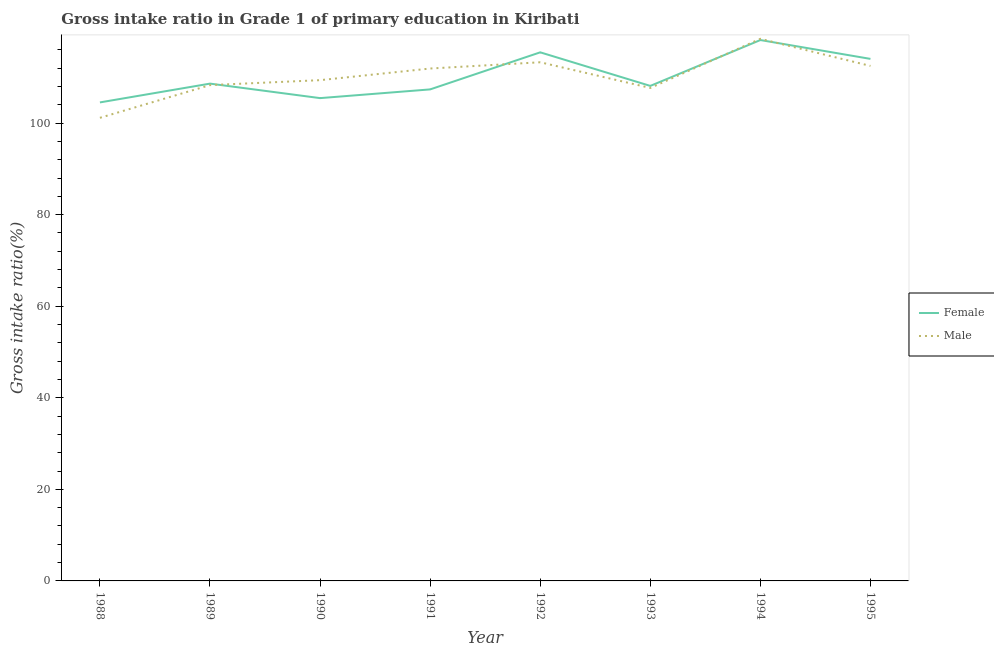Does the line corresponding to gross intake ratio(female) intersect with the line corresponding to gross intake ratio(male)?
Give a very brief answer. Yes. Is the number of lines equal to the number of legend labels?
Your answer should be compact. Yes. What is the gross intake ratio(female) in 1994?
Your answer should be very brief. 118.13. Across all years, what is the maximum gross intake ratio(male)?
Ensure brevity in your answer.  118.4. Across all years, what is the minimum gross intake ratio(female)?
Make the answer very short. 104.51. In which year was the gross intake ratio(female) maximum?
Offer a very short reply. 1994. In which year was the gross intake ratio(female) minimum?
Your answer should be compact. 1988. What is the total gross intake ratio(male) in the graph?
Offer a very short reply. 882.54. What is the difference between the gross intake ratio(male) in 1988 and that in 1989?
Give a very brief answer. -7.15. What is the difference between the gross intake ratio(male) in 1991 and the gross intake ratio(female) in 1988?
Ensure brevity in your answer.  7.4. What is the average gross intake ratio(male) per year?
Ensure brevity in your answer.  110.32. In the year 1990, what is the difference between the gross intake ratio(female) and gross intake ratio(male)?
Provide a short and direct response. -3.92. What is the ratio of the gross intake ratio(female) in 1989 to that in 1991?
Your response must be concise. 1.01. Is the gross intake ratio(female) in 1988 less than that in 1990?
Your answer should be very brief. Yes. Is the difference between the gross intake ratio(male) in 1994 and 1995 greater than the difference between the gross intake ratio(female) in 1994 and 1995?
Your answer should be compact. Yes. What is the difference between the highest and the second highest gross intake ratio(male)?
Your answer should be compact. 5.12. What is the difference between the highest and the lowest gross intake ratio(male)?
Provide a short and direct response. 17.25. In how many years, is the gross intake ratio(female) greater than the average gross intake ratio(female) taken over all years?
Give a very brief answer. 3. Is the gross intake ratio(male) strictly greater than the gross intake ratio(female) over the years?
Ensure brevity in your answer.  No. Is the gross intake ratio(female) strictly less than the gross intake ratio(male) over the years?
Provide a short and direct response. No. How many lines are there?
Give a very brief answer. 2. Are the values on the major ticks of Y-axis written in scientific E-notation?
Keep it short and to the point. No. Does the graph contain any zero values?
Offer a terse response. No. Does the graph contain grids?
Ensure brevity in your answer.  No. How many legend labels are there?
Your answer should be very brief. 2. What is the title of the graph?
Your response must be concise. Gross intake ratio in Grade 1 of primary education in Kiribati. Does "2012 US$" appear as one of the legend labels in the graph?
Offer a very short reply. No. What is the label or title of the X-axis?
Keep it short and to the point. Year. What is the label or title of the Y-axis?
Your response must be concise. Gross intake ratio(%). What is the Gross intake ratio(%) of Female in 1988?
Keep it short and to the point. 104.51. What is the Gross intake ratio(%) in Male in 1988?
Ensure brevity in your answer.  101.14. What is the Gross intake ratio(%) in Female in 1989?
Keep it short and to the point. 108.61. What is the Gross intake ratio(%) of Male in 1989?
Your answer should be very brief. 108.29. What is the Gross intake ratio(%) of Female in 1990?
Ensure brevity in your answer.  105.45. What is the Gross intake ratio(%) in Male in 1990?
Your answer should be compact. 109.37. What is the Gross intake ratio(%) in Female in 1991?
Your response must be concise. 107.35. What is the Gross intake ratio(%) in Male in 1991?
Provide a short and direct response. 111.91. What is the Gross intake ratio(%) in Female in 1992?
Ensure brevity in your answer.  115.45. What is the Gross intake ratio(%) of Male in 1992?
Your answer should be very brief. 113.28. What is the Gross intake ratio(%) in Female in 1993?
Keep it short and to the point. 108.11. What is the Gross intake ratio(%) of Male in 1993?
Your answer should be very brief. 107.67. What is the Gross intake ratio(%) of Female in 1994?
Your answer should be very brief. 118.13. What is the Gross intake ratio(%) of Male in 1994?
Offer a very short reply. 118.4. What is the Gross intake ratio(%) of Female in 1995?
Your answer should be compact. 114.01. What is the Gross intake ratio(%) in Male in 1995?
Provide a succinct answer. 112.48. Across all years, what is the maximum Gross intake ratio(%) of Female?
Give a very brief answer. 118.13. Across all years, what is the maximum Gross intake ratio(%) in Male?
Your answer should be very brief. 118.4. Across all years, what is the minimum Gross intake ratio(%) in Female?
Keep it short and to the point. 104.51. Across all years, what is the minimum Gross intake ratio(%) of Male?
Make the answer very short. 101.14. What is the total Gross intake ratio(%) in Female in the graph?
Keep it short and to the point. 881.62. What is the total Gross intake ratio(%) in Male in the graph?
Provide a succinct answer. 882.54. What is the difference between the Gross intake ratio(%) of Female in 1988 and that in 1989?
Provide a succinct answer. -4.1. What is the difference between the Gross intake ratio(%) in Male in 1988 and that in 1989?
Give a very brief answer. -7.15. What is the difference between the Gross intake ratio(%) in Female in 1988 and that in 1990?
Keep it short and to the point. -0.94. What is the difference between the Gross intake ratio(%) of Male in 1988 and that in 1990?
Provide a short and direct response. -8.23. What is the difference between the Gross intake ratio(%) of Female in 1988 and that in 1991?
Give a very brief answer. -2.84. What is the difference between the Gross intake ratio(%) in Male in 1988 and that in 1991?
Make the answer very short. -10.77. What is the difference between the Gross intake ratio(%) in Female in 1988 and that in 1992?
Make the answer very short. -10.93. What is the difference between the Gross intake ratio(%) of Male in 1988 and that in 1992?
Provide a succinct answer. -12.13. What is the difference between the Gross intake ratio(%) of Female in 1988 and that in 1993?
Your answer should be very brief. -3.6. What is the difference between the Gross intake ratio(%) of Male in 1988 and that in 1993?
Your answer should be compact. -6.53. What is the difference between the Gross intake ratio(%) of Female in 1988 and that in 1994?
Keep it short and to the point. -13.62. What is the difference between the Gross intake ratio(%) in Male in 1988 and that in 1994?
Offer a terse response. -17.25. What is the difference between the Gross intake ratio(%) of Female in 1988 and that in 1995?
Provide a short and direct response. -9.5. What is the difference between the Gross intake ratio(%) in Male in 1988 and that in 1995?
Provide a succinct answer. -11.33. What is the difference between the Gross intake ratio(%) in Female in 1989 and that in 1990?
Your answer should be very brief. 3.17. What is the difference between the Gross intake ratio(%) in Male in 1989 and that in 1990?
Make the answer very short. -1.08. What is the difference between the Gross intake ratio(%) of Female in 1989 and that in 1991?
Your response must be concise. 1.26. What is the difference between the Gross intake ratio(%) in Male in 1989 and that in 1991?
Give a very brief answer. -3.62. What is the difference between the Gross intake ratio(%) of Female in 1989 and that in 1992?
Your answer should be very brief. -6.83. What is the difference between the Gross intake ratio(%) of Male in 1989 and that in 1992?
Provide a short and direct response. -4.99. What is the difference between the Gross intake ratio(%) of Female in 1989 and that in 1993?
Your answer should be very brief. 0.5. What is the difference between the Gross intake ratio(%) in Male in 1989 and that in 1993?
Your answer should be compact. 0.62. What is the difference between the Gross intake ratio(%) in Female in 1989 and that in 1994?
Your answer should be compact. -9.52. What is the difference between the Gross intake ratio(%) in Male in 1989 and that in 1994?
Provide a short and direct response. -10.11. What is the difference between the Gross intake ratio(%) in Female in 1989 and that in 1995?
Your response must be concise. -5.4. What is the difference between the Gross intake ratio(%) in Male in 1989 and that in 1995?
Give a very brief answer. -4.19. What is the difference between the Gross intake ratio(%) of Female in 1990 and that in 1991?
Make the answer very short. -1.9. What is the difference between the Gross intake ratio(%) of Male in 1990 and that in 1991?
Provide a short and direct response. -2.54. What is the difference between the Gross intake ratio(%) of Female in 1990 and that in 1992?
Provide a short and direct response. -10. What is the difference between the Gross intake ratio(%) of Male in 1990 and that in 1992?
Your answer should be very brief. -3.91. What is the difference between the Gross intake ratio(%) in Female in 1990 and that in 1993?
Provide a succinct answer. -2.67. What is the difference between the Gross intake ratio(%) in Male in 1990 and that in 1993?
Give a very brief answer. 1.7. What is the difference between the Gross intake ratio(%) in Female in 1990 and that in 1994?
Your answer should be very brief. -12.68. What is the difference between the Gross intake ratio(%) of Male in 1990 and that in 1994?
Your answer should be very brief. -9.03. What is the difference between the Gross intake ratio(%) in Female in 1990 and that in 1995?
Provide a succinct answer. -8.57. What is the difference between the Gross intake ratio(%) of Male in 1990 and that in 1995?
Keep it short and to the point. -3.11. What is the difference between the Gross intake ratio(%) of Female in 1991 and that in 1992?
Your answer should be compact. -8.09. What is the difference between the Gross intake ratio(%) in Male in 1991 and that in 1992?
Provide a succinct answer. -1.37. What is the difference between the Gross intake ratio(%) in Female in 1991 and that in 1993?
Make the answer very short. -0.76. What is the difference between the Gross intake ratio(%) in Male in 1991 and that in 1993?
Provide a succinct answer. 4.24. What is the difference between the Gross intake ratio(%) of Female in 1991 and that in 1994?
Offer a terse response. -10.78. What is the difference between the Gross intake ratio(%) in Male in 1991 and that in 1994?
Your response must be concise. -6.49. What is the difference between the Gross intake ratio(%) in Female in 1991 and that in 1995?
Your answer should be compact. -6.66. What is the difference between the Gross intake ratio(%) of Male in 1991 and that in 1995?
Offer a very short reply. -0.57. What is the difference between the Gross intake ratio(%) in Female in 1992 and that in 1993?
Give a very brief answer. 7.33. What is the difference between the Gross intake ratio(%) in Male in 1992 and that in 1993?
Offer a terse response. 5.61. What is the difference between the Gross intake ratio(%) of Female in 1992 and that in 1994?
Make the answer very short. -2.68. What is the difference between the Gross intake ratio(%) in Male in 1992 and that in 1994?
Your answer should be very brief. -5.12. What is the difference between the Gross intake ratio(%) of Female in 1992 and that in 1995?
Provide a short and direct response. 1.43. What is the difference between the Gross intake ratio(%) in Male in 1992 and that in 1995?
Provide a short and direct response. 0.8. What is the difference between the Gross intake ratio(%) of Female in 1993 and that in 1994?
Offer a terse response. -10.02. What is the difference between the Gross intake ratio(%) of Male in 1993 and that in 1994?
Ensure brevity in your answer.  -10.73. What is the difference between the Gross intake ratio(%) of Female in 1993 and that in 1995?
Offer a terse response. -5.9. What is the difference between the Gross intake ratio(%) in Male in 1993 and that in 1995?
Your answer should be compact. -4.81. What is the difference between the Gross intake ratio(%) in Female in 1994 and that in 1995?
Make the answer very short. 4.12. What is the difference between the Gross intake ratio(%) in Male in 1994 and that in 1995?
Your answer should be compact. 5.92. What is the difference between the Gross intake ratio(%) of Female in 1988 and the Gross intake ratio(%) of Male in 1989?
Ensure brevity in your answer.  -3.78. What is the difference between the Gross intake ratio(%) in Female in 1988 and the Gross intake ratio(%) in Male in 1990?
Give a very brief answer. -4.86. What is the difference between the Gross intake ratio(%) in Female in 1988 and the Gross intake ratio(%) in Male in 1991?
Ensure brevity in your answer.  -7.4. What is the difference between the Gross intake ratio(%) of Female in 1988 and the Gross intake ratio(%) of Male in 1992?
Ensure brevity in your answer.  -8.77. What is the difference between the Gross intake ratio(%) of Female in 1988 and the Gross intake ratio(%) of Male in 1993?
Your answer should be compact. -3.16. What is the difference between the Gross intake ratio(%) in Female in 1988 and the Gross intake ratio(%) in Male in 1994?
Ensure brevity in your answer.  -13.89. What is the difference between the Gross intake ratio(%) of Female in 1988 and the Gross intake ratio(%) of Male in 1995?
Your answer should be very brief. -7.97. What is the difference between the Gross intake ratio(%) in Female in 1989 and the Gross intake ratio(%) in Male in 1990?
Your answer should be very brief. -0.76. What is the difference between the Gross intake ratio(%) in Female in 1989 and the Gross intake ratio(%) in Male in 1991?
Offer a terse response. -3.3. What is the difference between the Gross intake ratio(%) in Female in 1989 and the Gross intake ratio(%) in Male in 1992?
Give a very brief answer. -4.66. What is the difference between the Gross intake ratio(%) of Female in 1989 and the Gross intake ratio(%) of Male in 1993?
Your answer should be compact. 0.94. What is the difference between the Gross intake ratio(%) of Female in 1989 and the Gross intake ratio(%) of Male in 1994?
Keep it short and to the point. -9.78. What is the difference between the Gross intake ratio(%) of Female in 1989 and the Gross intake ratio(%) of Male in 1995?
Keep it short and to the point. -3.86. What is the difference between the Gross intake ratio(%) in Female in 1990 and the Gross intake ratio(%) in Male in 1991?
Your answer should be very brief. -6.46. What is the difference between the Gross intake ratio(%) in Female in 1990 and the Gross intake ratio(%) in Male in 1992?
Your response must be concise. -7.83. What is the difference between the Gross intake ratio(%) in Female in 1990 and the Gross intake ratio(%) in Male in 1993?
Provide a short and direct response. -2.22. What is the difference between the Gross intake ratio(%) of Female in 1990 and the Gross intake ratio(%) of Male in 1994?
Offer a terse response. -12.95. What is the difference between the Gross intake ratio(%) of Female in 1990 and the Gross intake ratio(%) of Male in 1995?
Your answer should be very brief. -7.03. What is the difference between the Gross intake ratio(%) of Female in 1991 and the Gross intake ratio(%) of Male in 1992?
Ensure brevity in your answer.  -5.93. What is the difference between the Gross intake ratio(%) of Female in 1991 and the Gross intake ratio(%) of Male in 1993?
Offer a terse response. -0.32. What is the difference between the Gross intake ratio(%) in Female in 1991 and the Gross intake ratio(%) in Male in 1994?
Give a very brief answer. -11.05. What is the difference between the Gross intake ratio(%) of Female in 1991 and the Gross intake ratio(%) of Male in 1995?
Offer a very short reply. -5.13. What is the difference between the Gross intake ratio(%) in Female in 1992 and the Gross intake ratio(%) in Male in 1993?
Ensure brevity in your answer.  7.77. What is the difference between the Gross intake ratio(%) in Female in 1992 and the Gross intake ratio(%) in Male in 1994?
Your response must be concise. -2.95. What is the difference between the Gross intake ratio(%) in Female in 1992 and the Gross intake ratio(%) in Male in 1995?
Provide a short and direct response. 2.97. What is the difference between the Gross intake ratio(%) of Female in 1993 and the Gross intake ratio(%) of Male in 1994?
Keep it short and to the point. -10.28. What is the difference between the Gross intake ratio(%) of Female in 1993 and the Gross intake ratio(%) of Male in 1995?
Your answer should be compact. -4.36. What is the difference between the Gross intake ratio(%) of Female in 1994 and the Gross intake ratio(%) of Male in 1995?
Your answer should be very brief. 5.65. What is the average Gross intake ratio(%) in Female per year?
Provide a short and direct response. 110.2. What is the average Gross intake ratio(%) in Male per year?
Offer a terse response. 110.32. In the year 1988, what is the difference between the Gross intake ratio(%) in Female and Gross intake ratio(%) in Male?
Your response must be concise. 3.37. In the year 1989, what is the difference between the Gross intake ratio(%) of Female and Gross intake ratio(%) of Male?
Offer a terse response. 0.32. In the year 1990, what is the difference between the Gross intake ratio(%) of Female and Gross intake ratio(%) of Male?
Provide a succinct answer. -3.92. In the year 1991, what is the difference between the Gross intake ratio(%) of Female and Gross intake ratio(%) of Male?
Provide a succinct answer. -4.56. In the year 1992, what is the difference between the Gross intake ratio(%) of Female and Gross intake ratio(%) of Male?
Ensure brevity in your answer.  2.17. In the year 1993, what is the difference between the Gross intake ratio(%) in Female and Gross intake ratio(%) in Male?
Your answer should be very brief. 0.44. In the year 1994, what is the difference between the Gross intake ratio(%) of Female and Gross intake ratio(%) of Male?
Give a very brief answer. -0.27. In the year 1995, what is the difference between the Gross intake ratio(%) in Female and Gross intake ratio(%) in Male?
Keep it short and to the point. 1.54. What is the ratio of the Gross intake ratio(%) in Female in 1988 to that in 1989?
Your answer should be very brief. 0.96. What is the ratio of the Gross intake ratio(%) of Male in 1988 to that in 1989?
Ensure brevity in your answer.  0.93. What is the ratio of the Gross intake ratio(%) in Male in 1988 to that in 1990?
Provide a succinct answer. 0.92. What is the ratio of the Gross intake ratio(%) of Female in 1988 to that in 1991?
Give a very brief answer. 0.97. What is the ratio of the Gross intake ratio(%) of Male in 1988 to that in 1991?
Your response must be concise. 0.9. What is the ratio of the Gross intake ratio(%) in Female in 1988 to that in 1992?
Provide a succinct answer. 0.91. What is the ratio of the Gross intake ratio(%) of Male in 1988 to that in 1992?
Offer a terse response. 0.89. What is the ratio of the Gross intake ratio(%) of Female in 1988 to that in 1993?
Your response must be concise. 0.97. What is the ratio of the Gross intake ratio(%) in Male in 1988 to that in 1993?
Provide a succinct answer. 0.94. What is the ratio of the Gross intake ratio(%) in Female in 1988 to that in 1994?
Keep it short and to the point. 0.88. What is the ratio of the Gross intake ratio(%) of Male in 1988 to that in 1994?
Your answer should be very brief. 0.85. What is the ratio of the Gross intake ratio(%) of Female in 1988 to that in 1995?
Provide a short and direct response. 0.92. What is the ratio of the Gross intake ratio(%) of Male in 1988 to that in 1995?
Your answer should be compact. 0.9. What is the ratio of the Gross intake ratio(%) in Female in 1989 to that in 1990?
Provide a succinct answer. 1.03. What is the ratio of the Gross intake ratio(%) in Female in 1989 to that in 1991?
Offer a terse response. 1.01. What is the ratio of the Gross intake ratio(%) in Male in 1989 to that in 1991?
Your answer should be very brief. 0.97. What is the ratio of the Gross intake ratio(%) of Female in 1989 to that in 1992?
Provide a short and direct response. 0.94. What is the ratio of the Gross intake ratio(%) in Male in 1989 to that in 1992?
Offer a very short reply. 0.96. What is the ratio of the Gross intake ratio(%) in Female in 1989 to that in 1993?
Make the answer very short. 1. What is the ratio of the Gross intake ratio(%) in Female in 1989 to that in 1994?
Keep it short and to the point. 0.92. What is the ratio of the Gross intake ratio(%) of Male in 1989 to that in 1994?
Provide a succinct answer. 0.91. What is the ratio of the Gross intake ratio(%) in Female in 1989 to that in 1995?
Offer a terse response. 0.95. What is the ratio of the Gross intake ratio(%) of Male in 1989 to that in 1995?
Your answer should be very brief. 0.96. What is the ratio of the Gross intake ratio(%) in Female in 1990 to that in 1991?
Your answer should be very brief. 0.98. What is the ratio of the Gross intake ratio(%) of Male in 1990 to that in 1991?
Ensure brevity in your answer.  0.98. What is the ratio of the Gross intake ratio(%) of Female in 1990 to that in 1992?
Offer a terse response. 0.91. What is the ratio of the Gross intake ratio(%) of Male in 1990 to that in 1992?
Give a very brief answer. 0.97. What is the ratio of the Gross intake ratio(%) in Female in 1990 to that in 1993?
Your answer should be very brief. 0.98. What is the ratio of the Gross intake ratio(%) of Male in 1990 to that in 1993?
Make the answer very short. 1.02. What is the ratio of the Gross intake ratio(%) of Female in 1990 to that in 1994?
Provide a short and direct response. 0.89. What is the ratio of the Gross intake ratio(%) in Male in 1990 to that in 1994?
Your answer should be very brief. 0.92. What is the ratio of the Gross intake ratio(%) of Female in 1990 to that in 1995?
Provide a short and direct response. 0.92. What is the ratio of the Gross intake ratio(%) in Male in 1990 to that in 1995?
Your response must be concise. 0.97. What is the ratio of the Gross intake ratio(%) in Female in 1991 to that in 1992?
Your answer should be compact. 0.93. What is the ratio of the Gross intake ratio(%) in Male in 1991 to that in 1992?
Your response must be concise. 0.99. What is the ratio of the Gross intake ratio(%) in Male in 1991 to that in 1993?
Your answer should be compact. 1.04. What is the ratio of the Gross intake ratio(%) in Female in 1991 to that in 1994?
Your answer should be very brief. 0.91. What is the ratio of the Gross intake ratio(%) of Male in 1991 to that in 1994?
Your response must be concise. 0.95. What is the ratio of the Gross intake ratio(%) of Female in 1991 to that in 1995?
Provide a succinct answer. 0.94. What is the ratio of the Gross intake ratio(%) in Female in 1992 to that in 1993?
Provide a succinct answer. 1.07. What is the ratio of the Gross intake ratio(%) of Male in 1992 to that in 1993?
Your response must be concise. 1.05. What is the ratio of the Gross intake ratio(%) in Female in 1992 to that in 1994?
Ensure brevity in your answer.  0.98. What is the ratio of the Gross intake ratio(%) in Male in 1992 to that in 1994?
Provide a succinct answer. 0.96. What is the ratio of the Gross intake ratio(%) in Female in 1992 to that in 1995?
Make the answer very short. 1.01. What is the ratio of the Gross intake ratio(%) of Male in 1992 to that in 1995?
Provide a short and direct response. 1.01. What is the ratio of the Gross intake ratio(%) in Female in 1993 to that in 1994?
Your answer should be very brief. 0.92. What is the ratio of the Gross intake ratio(%) of Male in 1993 to that in 1994?
Offer a very short reply. 0.91. What is the ratio of the Gross intake ratio(%) of Female in 1993 to that in 1995?
Offer a terse response. 0.95. What is the ratio of the Gross intake ratio(%) in Male in 1993 to that in 1995?
Make the answer very short. 0.96. What is the ratio of the Gross intake ratio(%) in Female in 1994 to that in 1995?
Your response must be concise. 1.04. What is the ratio of the Gross intake ratio(%) in Male in 1994 to that in 1995?
Ensure brevity in your answer.  1.05. What is the difference between the highest and the second highest Gross intake ratio(%) in Female?
Keep it short and to the point. 2.68. What is the difference between the highest and the second highest Gross intake ratio(%) of Male?
Ensure brevity in your answer.  5.12. What is the difference between the highest and the lowest Gross intake ratio(%) in Female?
Keep it short and to the point. 13.62. What is the difference between the highest and the lowest Gross intake ratio(%) of Male?
Provide a succinct answer. 17.25. 